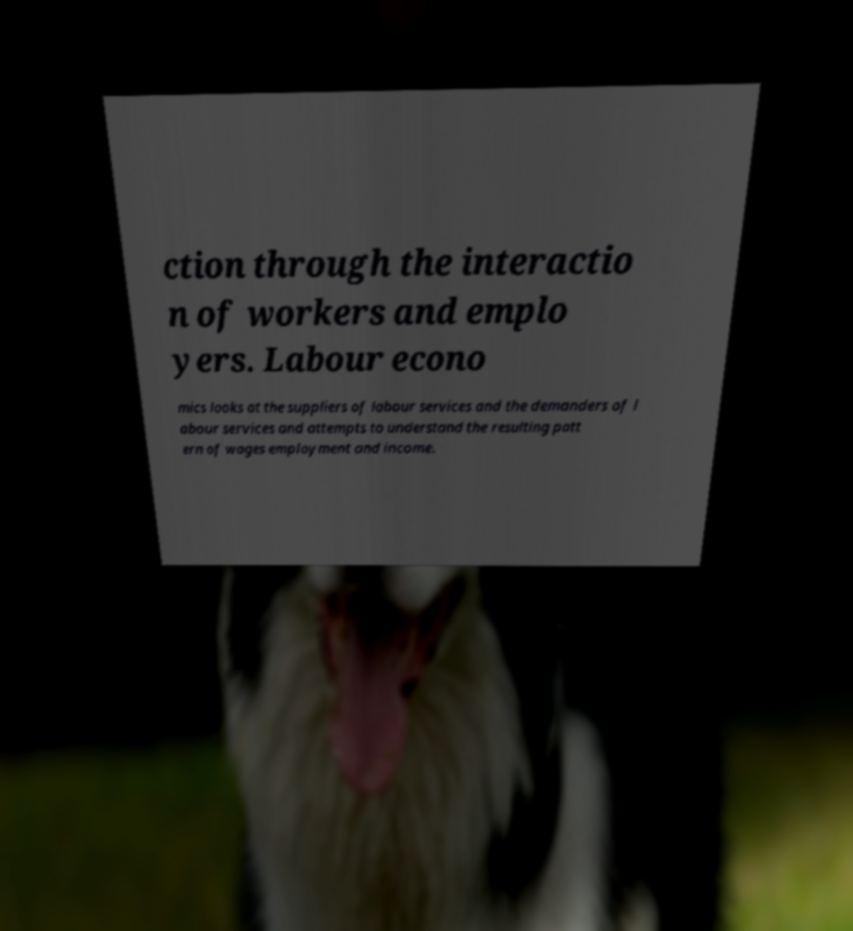Can you read and provide the text displayed in the image?This photo seems to have some interesting text. Can you extract and type it out for me? ction through the interactio n of workers and emplo yers. Labour econo mics looks at the suppliers of labour services and the demanders of l abour services and attempts to understand the resulting patt ern of wages employment and income. 